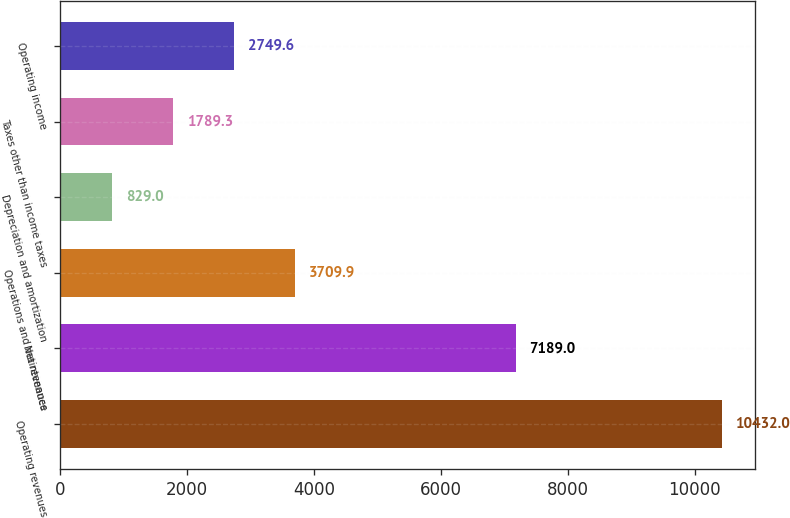Convert chart. <chart><loc_0><loc_0><loc_500><loc_500><bar_chart><fcel>Operating revenues<fcel>Net revenues<fcel>Operations and maintenance<fcel>Depreciation and amortization<fcel>Taxes other than income taxes<fcel>Operating income<nl><fcel>10432<fcel>7189<fcel>3709.9<fcel>829<fcel>1789.3<fcel>2749.6<nl></chart> 